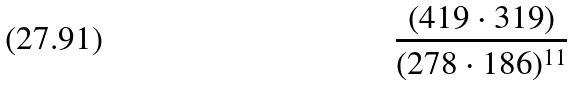<formula> <loc_0><loc_0><loc_500><loc_500>\frac { ( 4 1 9 \cdot 3 1 9 ) } { ( 2 7 8 \cdot 1 8 6 ) ^ { 1 1 } }</formula> 